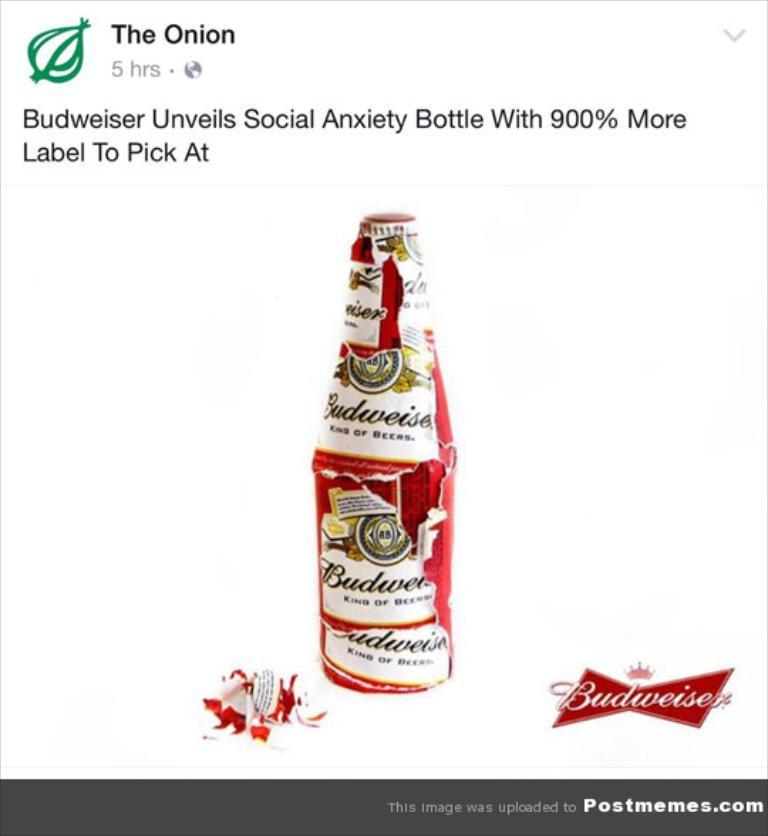<image>
Create a compact narrative representing the image presented. a social media post has a Budweiser Social Anxiety bottle 